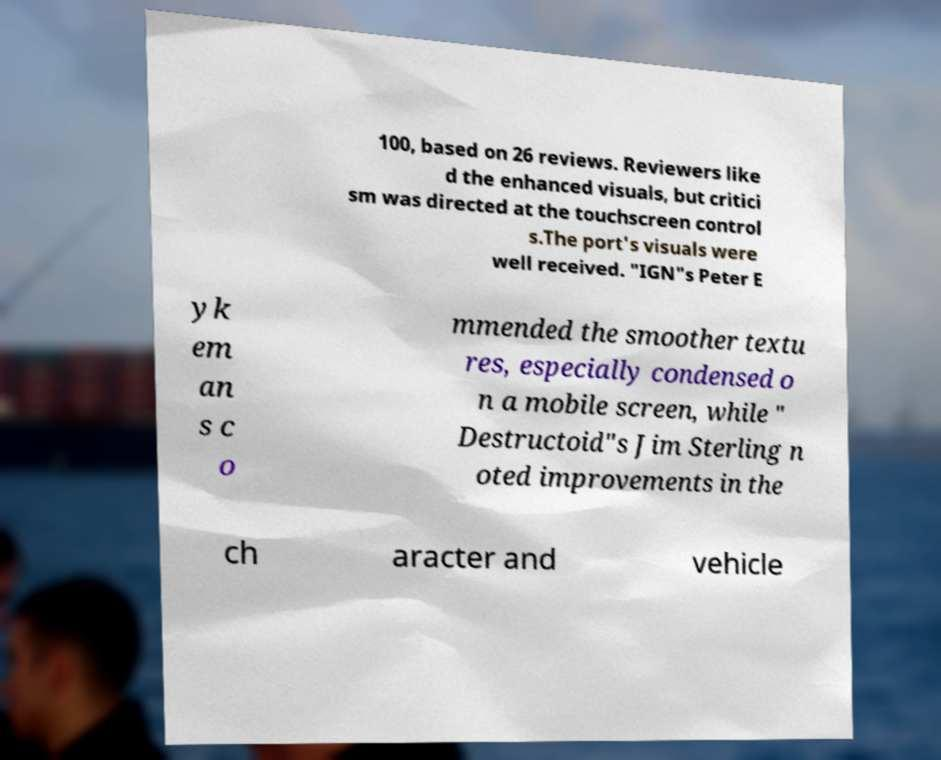Can you accurately transcribe the text from the provided image for me? 100, based on 26 reviews. Reviewers like d the enhanced visuals, but critici sm was directed at the touchscreen control s.The port's visuals were well received. "IGN"s Peter E yk em an s c o mmended the smoother textu res, especially condensed o n a mobile screen, while " Destructoid"s Jim Sterling n oted improvements in the ch aracter and vehicle 